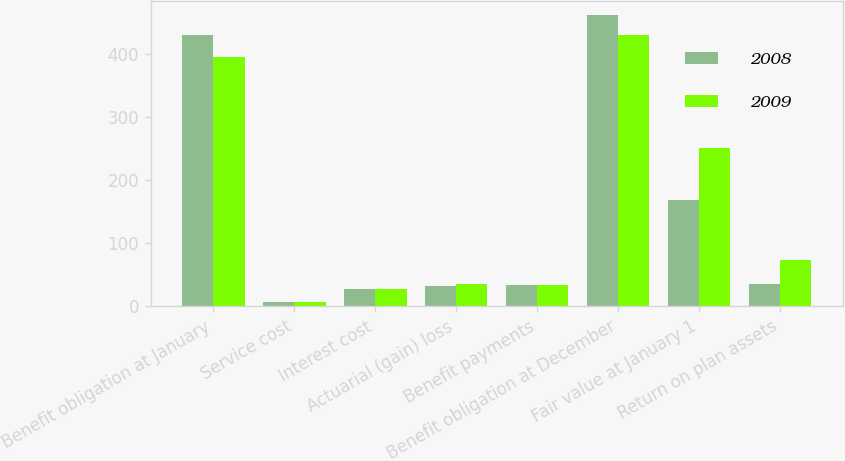Convert chart to OTSL. <chart><loc_0><loc_0><loc_500><loc_500><stacked_bar_chart><ecel><fcel>Benefit obligation at January<fcel>Service cost<fcel>Interest cost<fcel>Actuarial (gain) loss<fcel>Benefit payments<fcel>Benefit obligation at December<fcel>Fair value at January 1<fcel>Return on plan assets<nl><fcel>2008<fcel>429<fcel>6<fcel>27<fcel>32<fcel>33<fcel>461<fcel>168<fcel>35<nl><fcel>2009<fcel>395<fcel>6<fcel>26<fcel>35<fcel>33<fcel>429<fcel>251<fcel>73<nl></chart> 